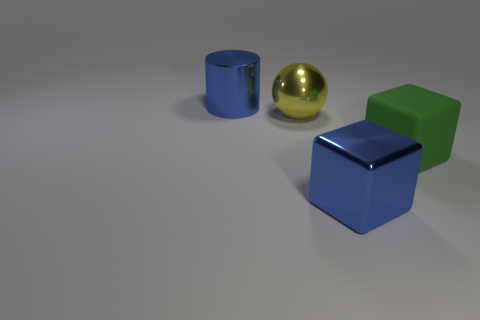Are there any red rubber objects?
Your answer should be very brief. No. There is a cube that is the same material as the large cylinder; what size is it?
Keep it short and to the point. Large. Are there any large metallic blocks that have the same color as the cylinder?
Make the answer very short. Yes. There is a cube that is to the left of the large green cube; does it have the same color as the large sphere to the left of the big green matte thing?
Keep it short and to the point. No. What size is the metal cylinder that is the same color as the big metal cube?
Offer a very short reply. Large. Are there any small cyan cubes that have the same material as the big sphere?
Provide a short and direct response. No. The large metal ball is what color?
Give a very brief answer. Yellow. What is the size of the metal object that is in front of the large thing that is on the right side of the metal object in front of the large matte block?
Keep it short and to the point. Large. What number of other things are there of the same shape as the yellow shiny thing?
Your answer should be very brief. 0. What color is the shiny thing that is both behind the large green object and in front of the large cylinder?
Your answer should be compact. Yellow. 